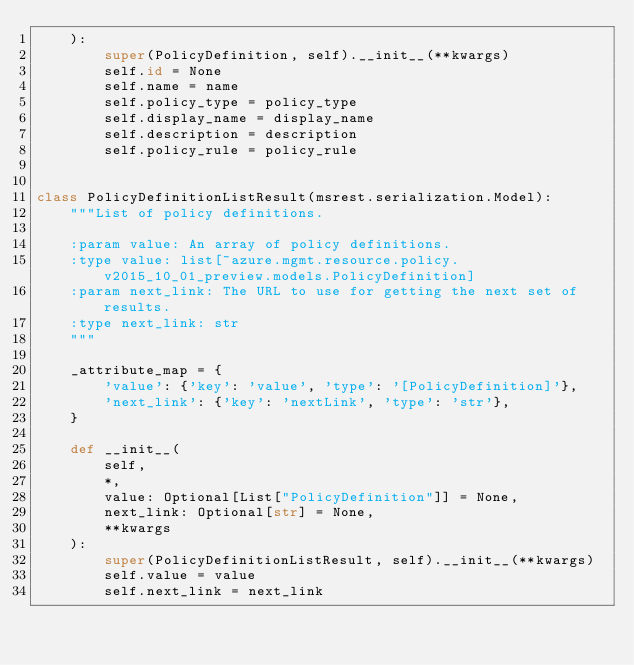<code> <loc_0><loc_0><loc_500><loc_500><_Python_>    ):
        super(PolicyDefinition, self).__init__(**kwargs)
        self.id = None
        self.name = name
        self.policy_type = policy_type
        self.display_name = display_name
        self.description = description
        self.policy_rule = policy_rule


class PolicyDefinitionListResult(msrest.serialization.Model):
    """List of policy definitions.

    :param value: An array of policy definitions.
    :type value: list[~azure.mgmt.resource.policy.v2015_10_01_preview.models.PolicyDefinition]
    :param next_link: The URL to use for getting the next set of results.
    :type next_link: str
    """

    _attribute_map = {
        'value': {'key': 'value', 'type': '[PolicyDefinition]'},
        'next_link': {'key': 'nextLink', 'type': 'str'},
    }

    def __init__(
        self,
        *,
        value: Optional[List["PolicyDefinition"]] = None,
        next_link: Optional[str] = None,
        **kwargs
    ):
        super(PolicyDefinitionListResult, self).__init__(**kwargs)
        self.value = value
        self.next_link = next_link
</code> 